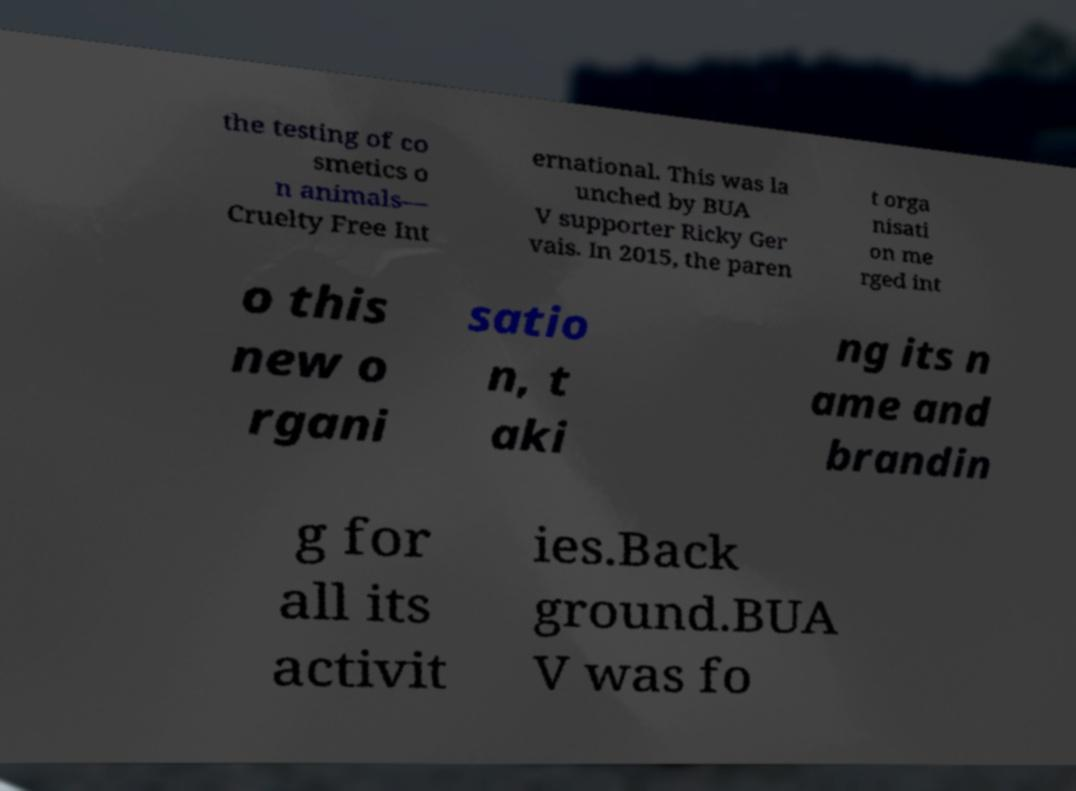What messages or text are displayed in this image? I need them in a readable, typed format. the testing of co smetics o n animals— Cruelty Free Int ernational. This was la unched by BUA V supporter Ricky Ger vais. In 2015, the paren t orga nisati on me rged int o this new o rgani satio n, t aki ng its n ame and brandin g for all its activit ies.Back ground.BUA V was fo 